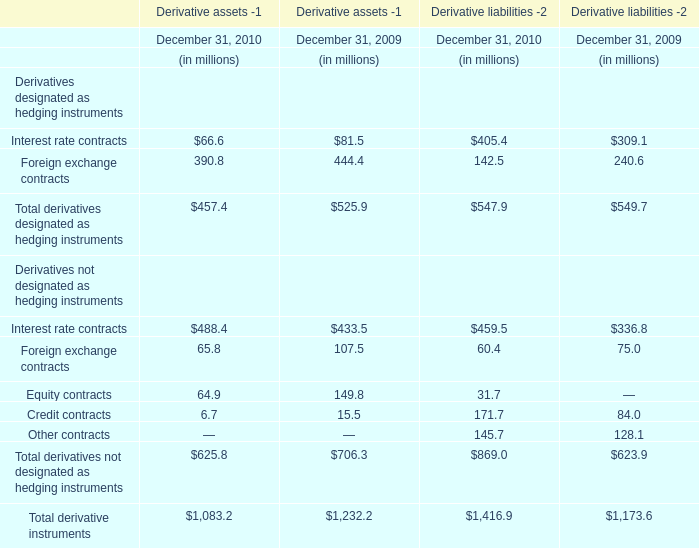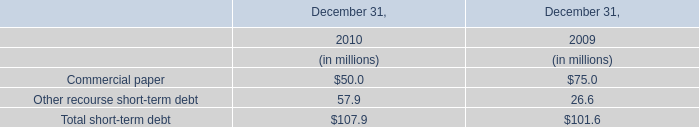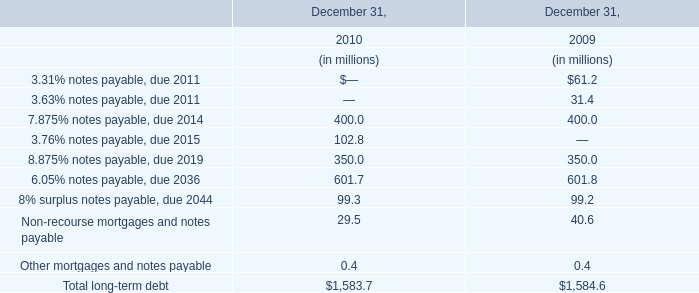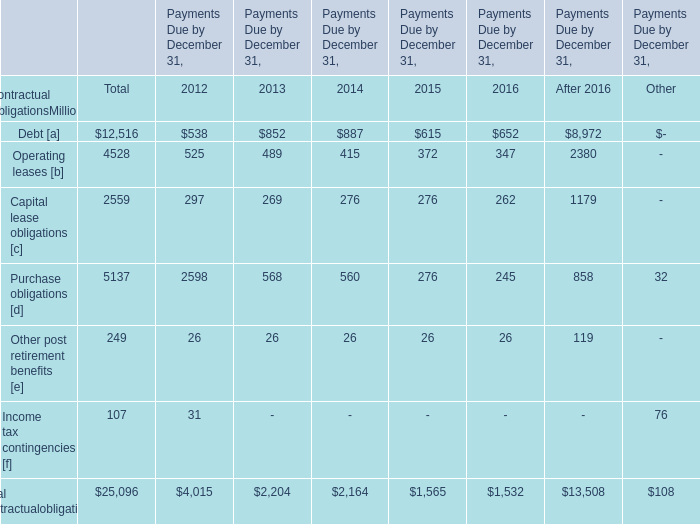What was the sum of contractual obligations without those contractual obligations smaller than 3000 ( in total)? (in million) 
Computations: ((12516 + 4528) + 5137)
Answer: 22181.0. 